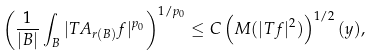Convert formula to latex. <formula><loc_0><loc_0><loc_500><loc_500>\left ( \frac { 1 } { | B | } \int _ { B } | T A _ { r ( B ) } f | ^ { p _ { 0 } } \right ) ^ { 1 / p _ { 0 } } \leq C \left ( { M } ( | T f | ^ { 2 } ) \right ) ^ { 1 / 2 } ( y ) ,</formula> 